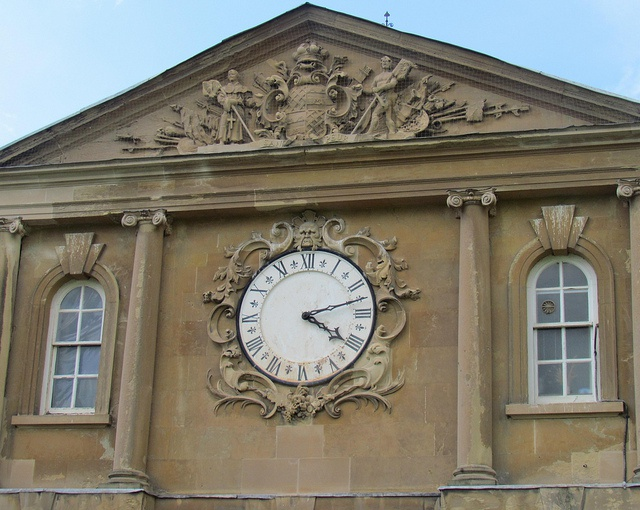Describe the objects in this image and their specific colors. I can see a clock in lightblue, lightgray, darkgray, and gray tones in this image. 